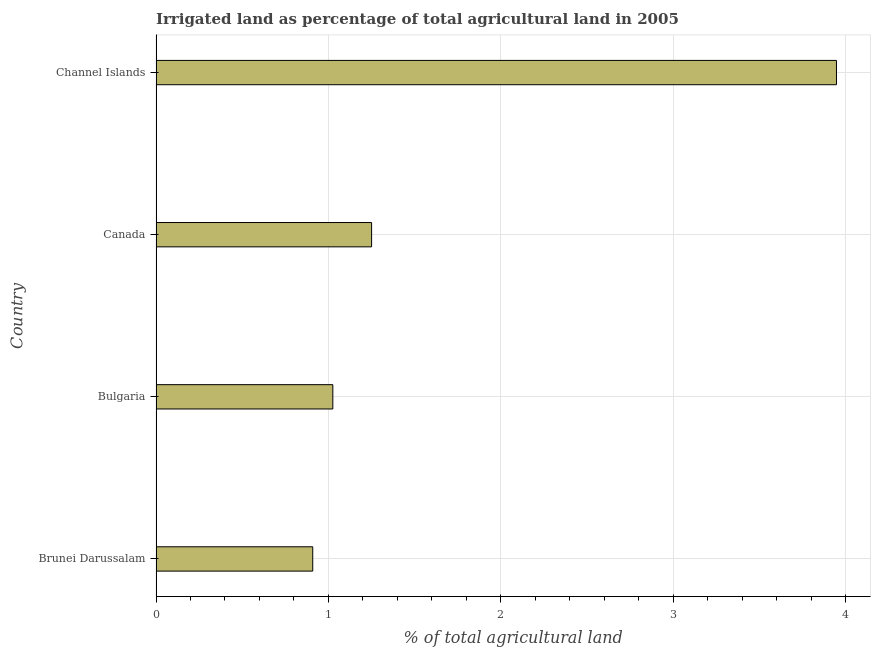Does the graph contain grids?
Offer a very short reply. Yes. What is the title of the graph?
Offer a terse response. Irrigated land as percentage of total agricultural land in 2005. What is the label or title of the X-axis?
Make the answer very short. % of total agricultural land. What is the label or title of the Y-axis?
Offer a terse response. Country. What is the percentage of agricultural irrigated land in Bulgaria?
Give a very brief answer. 1.03. Across all countries, what is the maximum percentage of agricultural irrigated land?
Provide a succinct answer. 3.95. Across all countries, what is the minimum percentage of agricultural irrigated land?
Your answer should be compact. 0.91. In which country was the percentage of agricultural irrigated land maximum?
Provide a short and direct response. Channel Islands. In which country was the percentage of agricultural irrigated land minimum?
Keep it short and to the point. Brunei Darussalam. What is the sum of the percentage of agricultural irrigated land?
Offer a terse response. 7.13. What is the difference between the percentage of agricultural irrigated land in Brunei Darussalam and Canada?
Your answer should be very brief. -0.34. What is the average percentage of agricultural irrigated land per country?
Keep it short and to the point. 1.78. What is the median percentage of agricultural irrigated land?
Offer a terse response. 1.14. In how many countries, is the percentage of agricultural irrigated land greater than 1.6 %?
Your answer should be very brief. 1. What is the ratio of the percentage of agricultural irrigated land in Brunei Darussalam to that in Bulgaria?
Make the answer very short. 0.89. Is the difference between the percentage of agricultural irrigated land in Bulgaria and Channel Islands greater than the difference between any two countries?
Offer a very short reply. No. What is the difference between the highest and the second highest percentage of agricultural irrigated land?
Give a very brief answer. 2.7. What is the difference between the highest and the lowest percentage of agricultural irrigated land?
Your response must be concise. 3.04. Are all the bars in the graph horizontal?
Provide a short and direct response. Yes. Are the values on the major ticks of X-axis written in scientific E-notation?
Provide a short and direct response. No. What is the % of total agricultural land in Brunei Darussalam?
Ensure brevity in your answer.  0.91. What is the % of total agricultural land of Bulgaria?
Offer a very short reply. 1.03. What is the % of total agricultural land of Canada?
Your answer should be compact. 1.25. What is the % of total agricultural land in Channel Islands?
Your answer should be very brief. 3.95. What is the difference between the % of total agricultural land in Brunei Darussalam and Bulgaria?
Your answer should be very brief. -0.12. What is the difference between the % of total agricultural land in Brunei Darussalam and Canada?
Give a very brief answer. -0.34. What is the difference between the % of total agricultural land in Brunei Darussalam and Channel Islands?
Give a very brief answer. -3.04. What is the difference between the % of total agricultural land in Bulgaria and Canada?
Give a very brief answer. -0.22. What is the difference between the % of total agricultural land in Bulgaria and Channel Islands?
Your answer should be compact. -2.92. What is the difference between the % of total agricultural land in Canada and Channel Islands?
Provide a short and direct response. -2.7. What is the ratio of the % of total agricultural land in Brunei Darussalam to that in Bulgaria?
Provide a succinct answer. 0.89. What is the ratio of the % of total agricultural land in Brunei Darussalam to that in Canada?
Provide a succinct answer. 0.73. What is the ratio of the % of total agricultural land in Brunei Darussalam to that in Channel Islands?
Your answer should be very brief. 0.23. What is the ratio of the % of total agricultural land in Bulgaria to that in Canada?
Offer a terse response. 0.82. What is the ratio of the % of total agricultural land in Bulgaria to that in Channel Islands?
Offer a very short reply. 0.26. What is the ratio of the % of total agricultural land in Canada to that in Channel Islands?
Your answer should be very brief. 0.32. 